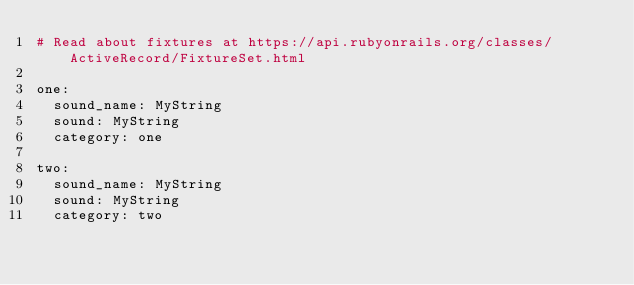<code> <loc_0><loc_0><loc_500><loc_500><_YAML_># Read about fixtures at https://api.rubyonrails.org/classes/ActiveRecord/FixtureSet.html

one:
  sound_name: MyString
  sound: MyString
  category: one

two:
  sound_name: MyString
  sound: MyString
  category: two
</code> 